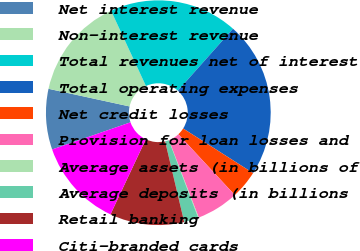Convert chart to OTSL. <chart><loc_0><loc_0><loc_500><loc_500><pie_chart><fcel>Net interest revenue<fcel>Non-interest revenue<fcel>Total revenues net of interest<fcel>Total operating expenses<fcel>Net credit losses<fcel>Provision for loan losses and<fcel>Average assets (in billions of<fcel>Average deposits (in billions<fcel>Retail banking<fcel>Citi-branded cards<nl><fcel>8.72%<fcel>14.68%<fcel>18.48%<fcel>22.46%<fcel>4.06%<fcel>6.05%<fcel>0.09%<fcel>2.07%<fcel>10.7%<fcel>12.69%<nl></chart> 